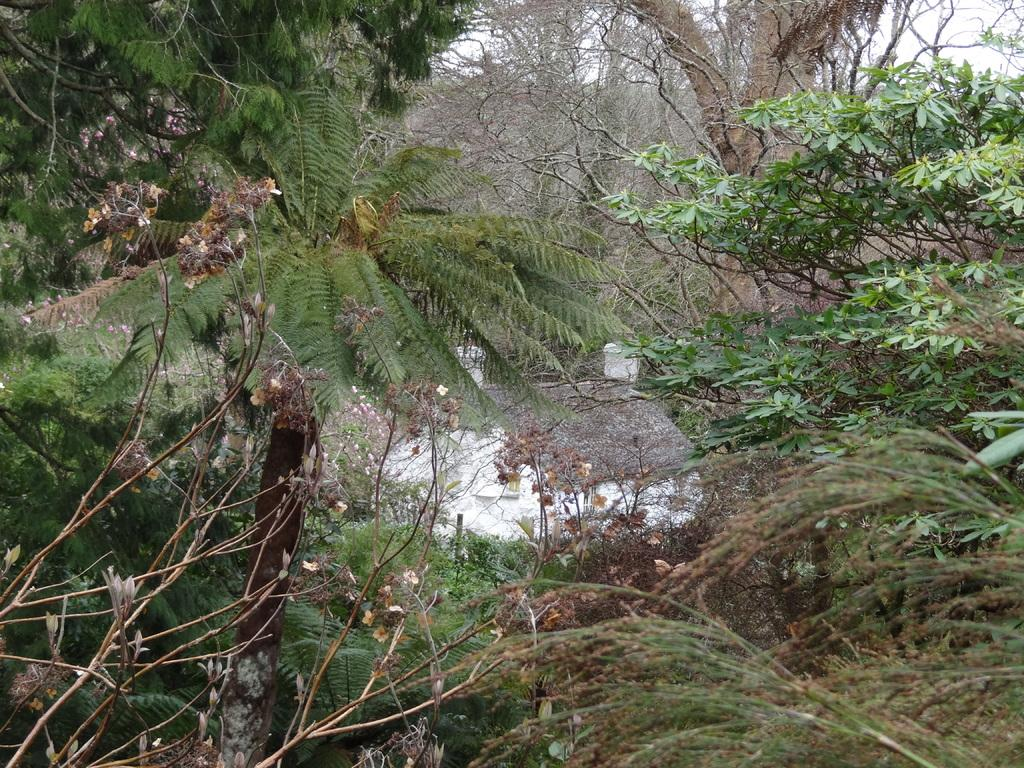What type of vegetation can be seen in the image? There are trees in the image. What geological feature is present in the image? There is a rock in the image. What part of the natural environment is visible in the background of the image? The sky is visible in the background of the image. What letter is being used to build the rock formation in the image? There is no letter being used to build the rock formation in the image; it is a natural geological feature. 